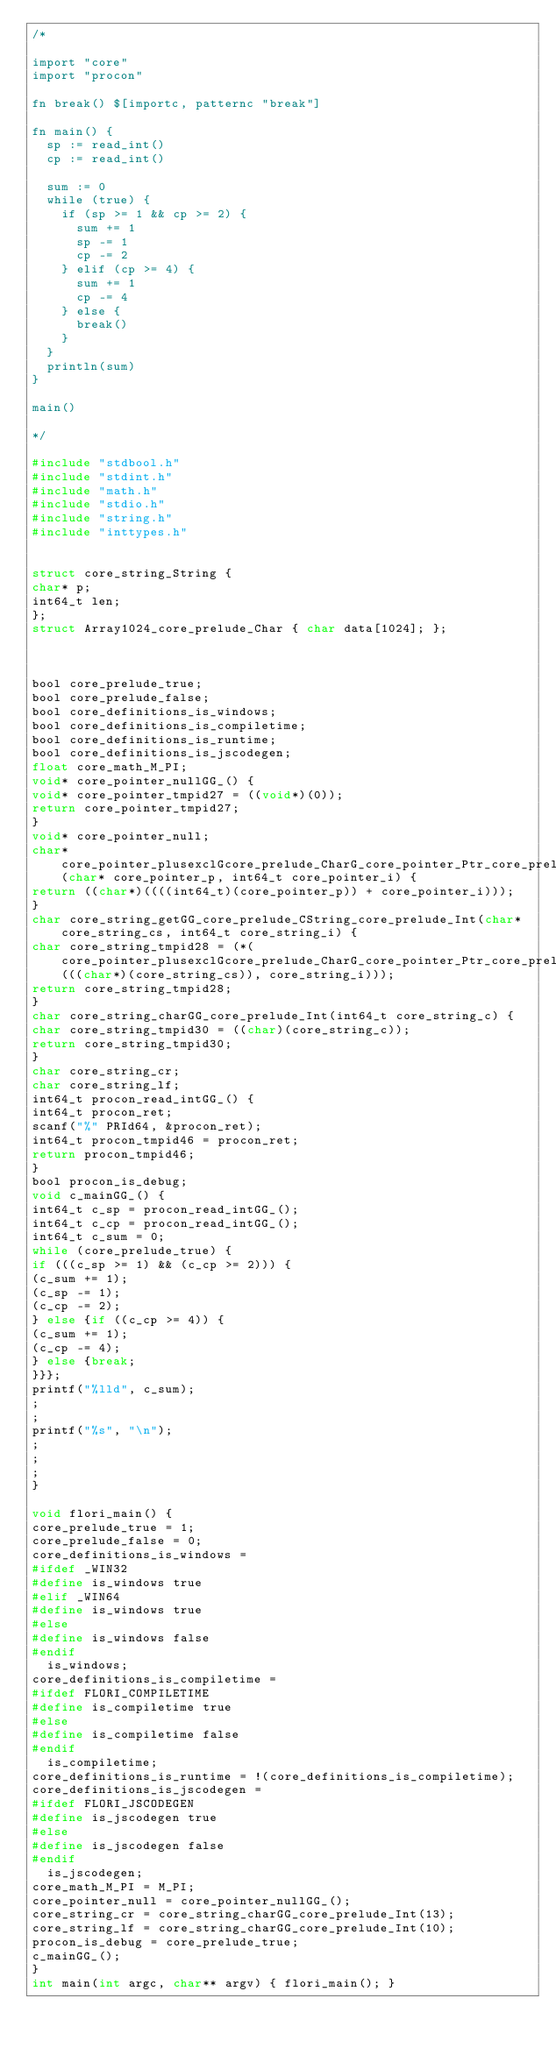<code> <loc_0><loc_0><loc_500><loc_500><_C_>/*

import "core"
import "procon"

fn break() $[importc, patternc "break"]

fn main() {
  sp := read_int()
  cp := read_int()

  sum := 0
  while (true) {
    if (sp >= 1 && cp >= 2) {
      sum += 1
      sp -= 1
      cp -= 2
    } elif (cp >= 4) {
      sum += 1
      cp -= 4
    } else {
      break()
    }
  }
  println(sum)
}

main()

*/

#include "stdbool.h"
#include "stdint.h"
#include "math.h"
#include "stdio.h"
#include "string.h"
#include "inttypes.h"


struct core_string_String {
char* p;
int64_t len;
};
struct Array1024_core_prelude_Char { char data[1024]; };



bool core_prelude_true;
bool core_prelude_false;
bool core_definitions_is_windows;
bool core_definitions_is_compiletime;
bool core_definitions_is_runtime;
bool core_definitions_is_jscodegen;
float core_math_M_PI;
void* core_pointer_nullGG_() {
void* core_pointer_tmpid27 = ((void*)(0));
return core_pointer_tmpid27;
}
void* core_pointer_null;
char* core_pointer_plusexclGcore_prelude_CharG_core_pointer_Ptr_core_prelude_Char_core_prelude_Int(char* core_pointer_p, int64_t core_pointer_i) {
return ((char*)((((int64_t)(core_pointer_p)) + core_pointer_i)));
}
char core_string_getGG_core_prelude_CString_core_prelude_Int(char* core_string_cs, int64_t core_string_i) {
char core_string_tmpid28 = (*(core_pointer_plusexclGcore_prelude_CharG_core_pointer_Ptr_core_prelude_Char_core_prelude_Int(((char*)(core_string_cs)), core_string_i)));
return core_string_tmpid28;
}
char core_string_charGG_core_prelude_Int(int64_t core_string_c) {
char core_string_tmpid30 = ((char)(core_string_c));
return core_string_tmpid30;
}
char core_string_cr;
char core_string_lf;
int64_t procon_read_intGG_() {
int64_t procon_ret;
scanf("%" PRId64, &procon_ret);
int64_t procon_tmpid46 = procon_ret;
return procon_tmpid46;
}
bool procon_is_debug;
void c_mainGG_() {
int64_t c_sp = procon_read_intGG_();
int64_t c_cp = procon_read_intGG_();
int64_t c_sum = 0;
while (core_prelude_true) {
if (((c_sp >= 1) && (c_cp >= 2))) {
(c_sum += 1);
(c_sp -= 1);
(c_cp -= 2);
} else {if ((c_cp >= 4)) {
(c_sum += 1);
(c_cp -= 4);
} else {break;
}}};
printf("%lld", c_sum);
;
;
printf("%s", "\n");
;
;
;
}

void flori_main() {
core_prelude_true = 1;
core_prelude_false = 0;
core_definitions_is_windows = 
#ifdef _WIN32
#define is_windows true
#elif _WIN64
#define is_windows true
#else
#define is_windows false
#endif
  is_windows;
core_definitions_is_compiletime = 
#ifdef FLORI_COMPILETIME
#define is_compiletime true
#else
#define is_compiletime false
#endif
  is_compiletime;
core_definitions_is_runtime = !(core_definitions_is_compiletime);
core_definitions_is_jscodegen = 
#ifdef FLORI_JSCODEGEN
#define is_jscodegen true
#else
#define is_jscodegen false
#endif
  is_jscodegen;
core_math_M_PI = M_PI;
core_pointer_null = core_pointer_nullGG_();
core_string_cr = core_string_charGG_core_prelude_Int(13);
core_string_lf = core_string_charGG_core_prelude_Int(10);
procon_is_debug = core_prelude_true;
c_mainGG_();
}
int main(int argc, char** argv) { flori_main(); }
</code> 